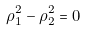<formula> <loc_0><loc_0><loc_500><loc_500>\rho _ { 1 } ^ { 2 } - \rho _ { 2 } ^ { 2 } = 0</formula> 